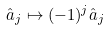<formula> <loc_0><loc_0><loc_500><loc_500>\hat { a } _ { j } \mapsto ( - 1 ) ^ { j } \hat { a } _ { j }</formula> 